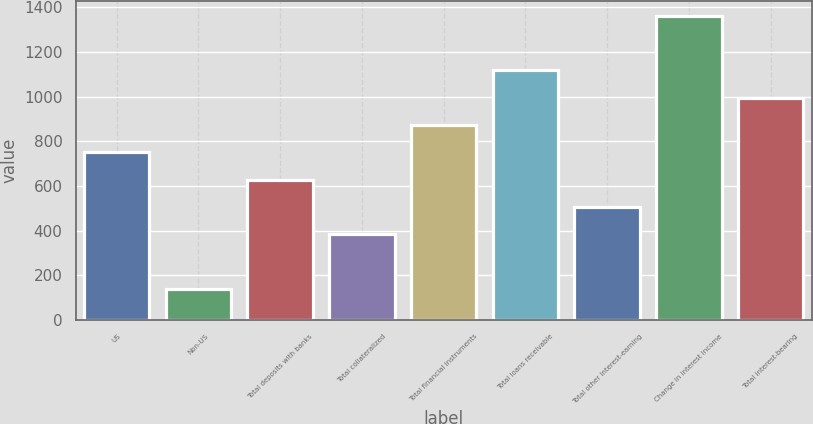Convert chart to OTSL. <chart><loc_0><loc_0><loc_500><loc_500><bar_chart><fcel>US<fcel>Non-US<fcel>Total deposits with banks<fcel>Total collateralized<fcel>Total financial instruments<fcel>Total loans receivable<fcel>Total other interest-earning<fcel>Change in interest income<fcel>Total interest-bearing<nl><fcel>750.2<fcel>139.2<fcel>628<fcel>383.6<fcel>872.4<fcel>1116.8<fcel>505.8<fcel>1361.2<fcel>994.6<nl></chart> 